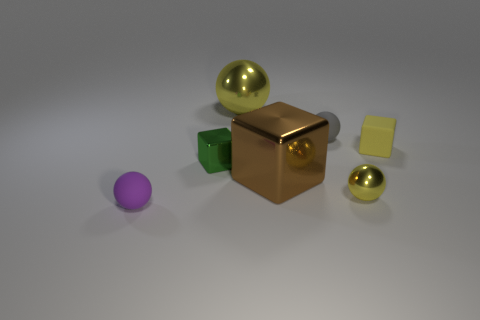Add 1 metallic objects. How many objects exist? 8 Subtract all spheres. How many objects are left? 3 Add 2 big metallic things. How many big metallic things exist? 4 Subtract 1 purple balls. How many objects are left? 6 Subtract all small matte objects. Subtract all tiny balls. How many objects are left? 1 Add 3 small green metallic objects. How many small green metallic objects are left? 4 